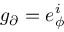<formula> <loc_0><loc_0><loc_500><loc_500>g _ { \partial } = e _ { \phi } ^ { i }</formula> 